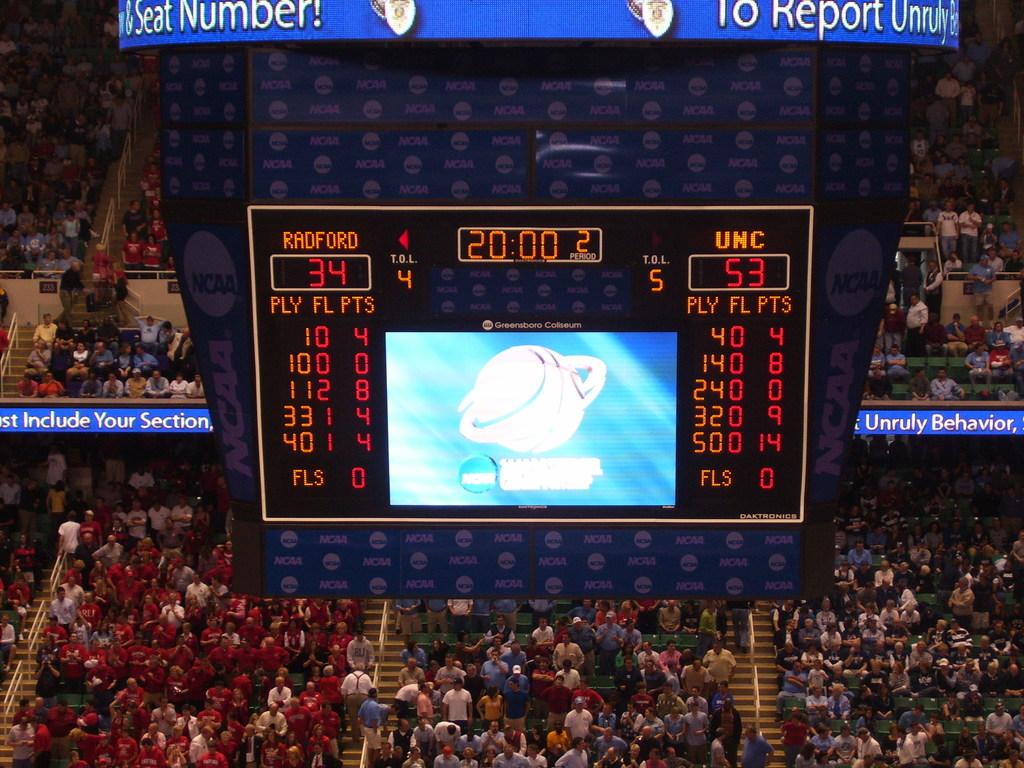Which teams are playing?
Provide a short and direct response. Radford and unc. 